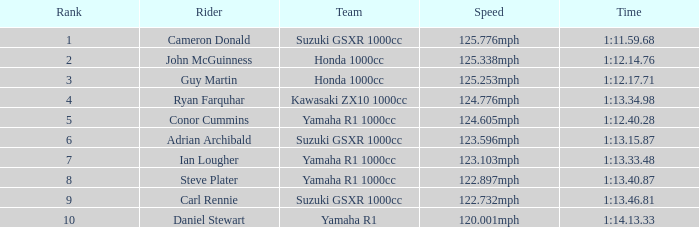28? 5.0. 